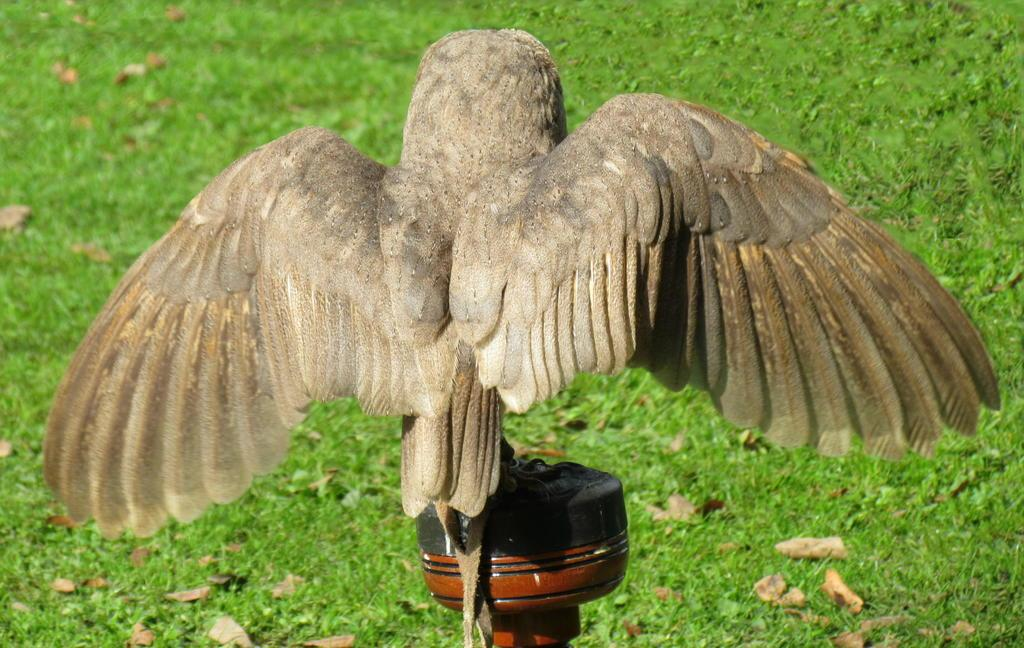What type of animal can be seen in the image? There is a bird in the image. What is the bird standing on? The bird is standing on a black color pole. Can you describe the bird's appearance? The bird is in cream color. What can be seen on the ground in the image? There are dried leaves on the ground. What type of vegetation is visible in the image? There is grass visible in the image. How many cherries are hanging from the bird's feathers in the image? There are no cherries present in the image, and the bird does not have any feathers visible. 